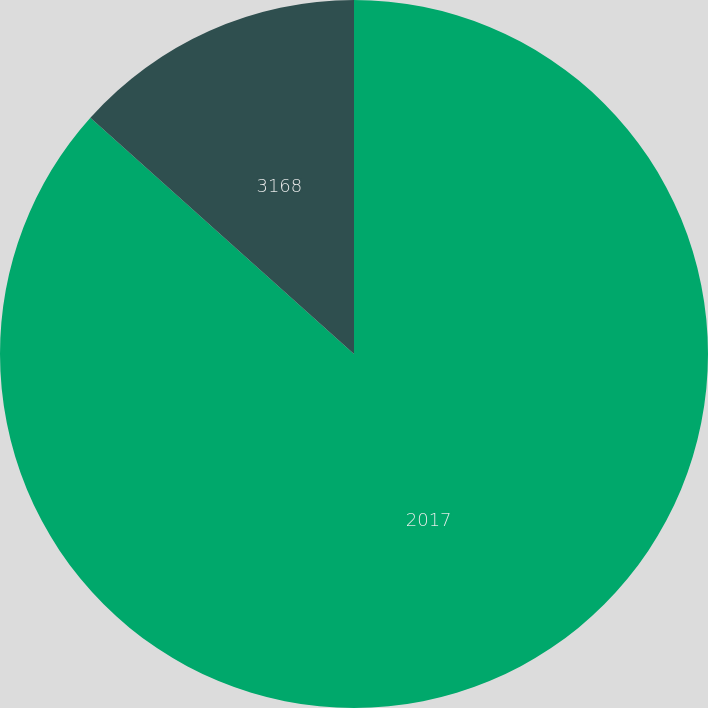<chart> <loc_0><loc_0><loc_500><loc_500><pie_chart><fcel>2017<fcel>3168<nl><fcel>86.63%<fcel>13.37%<nl></chart> 